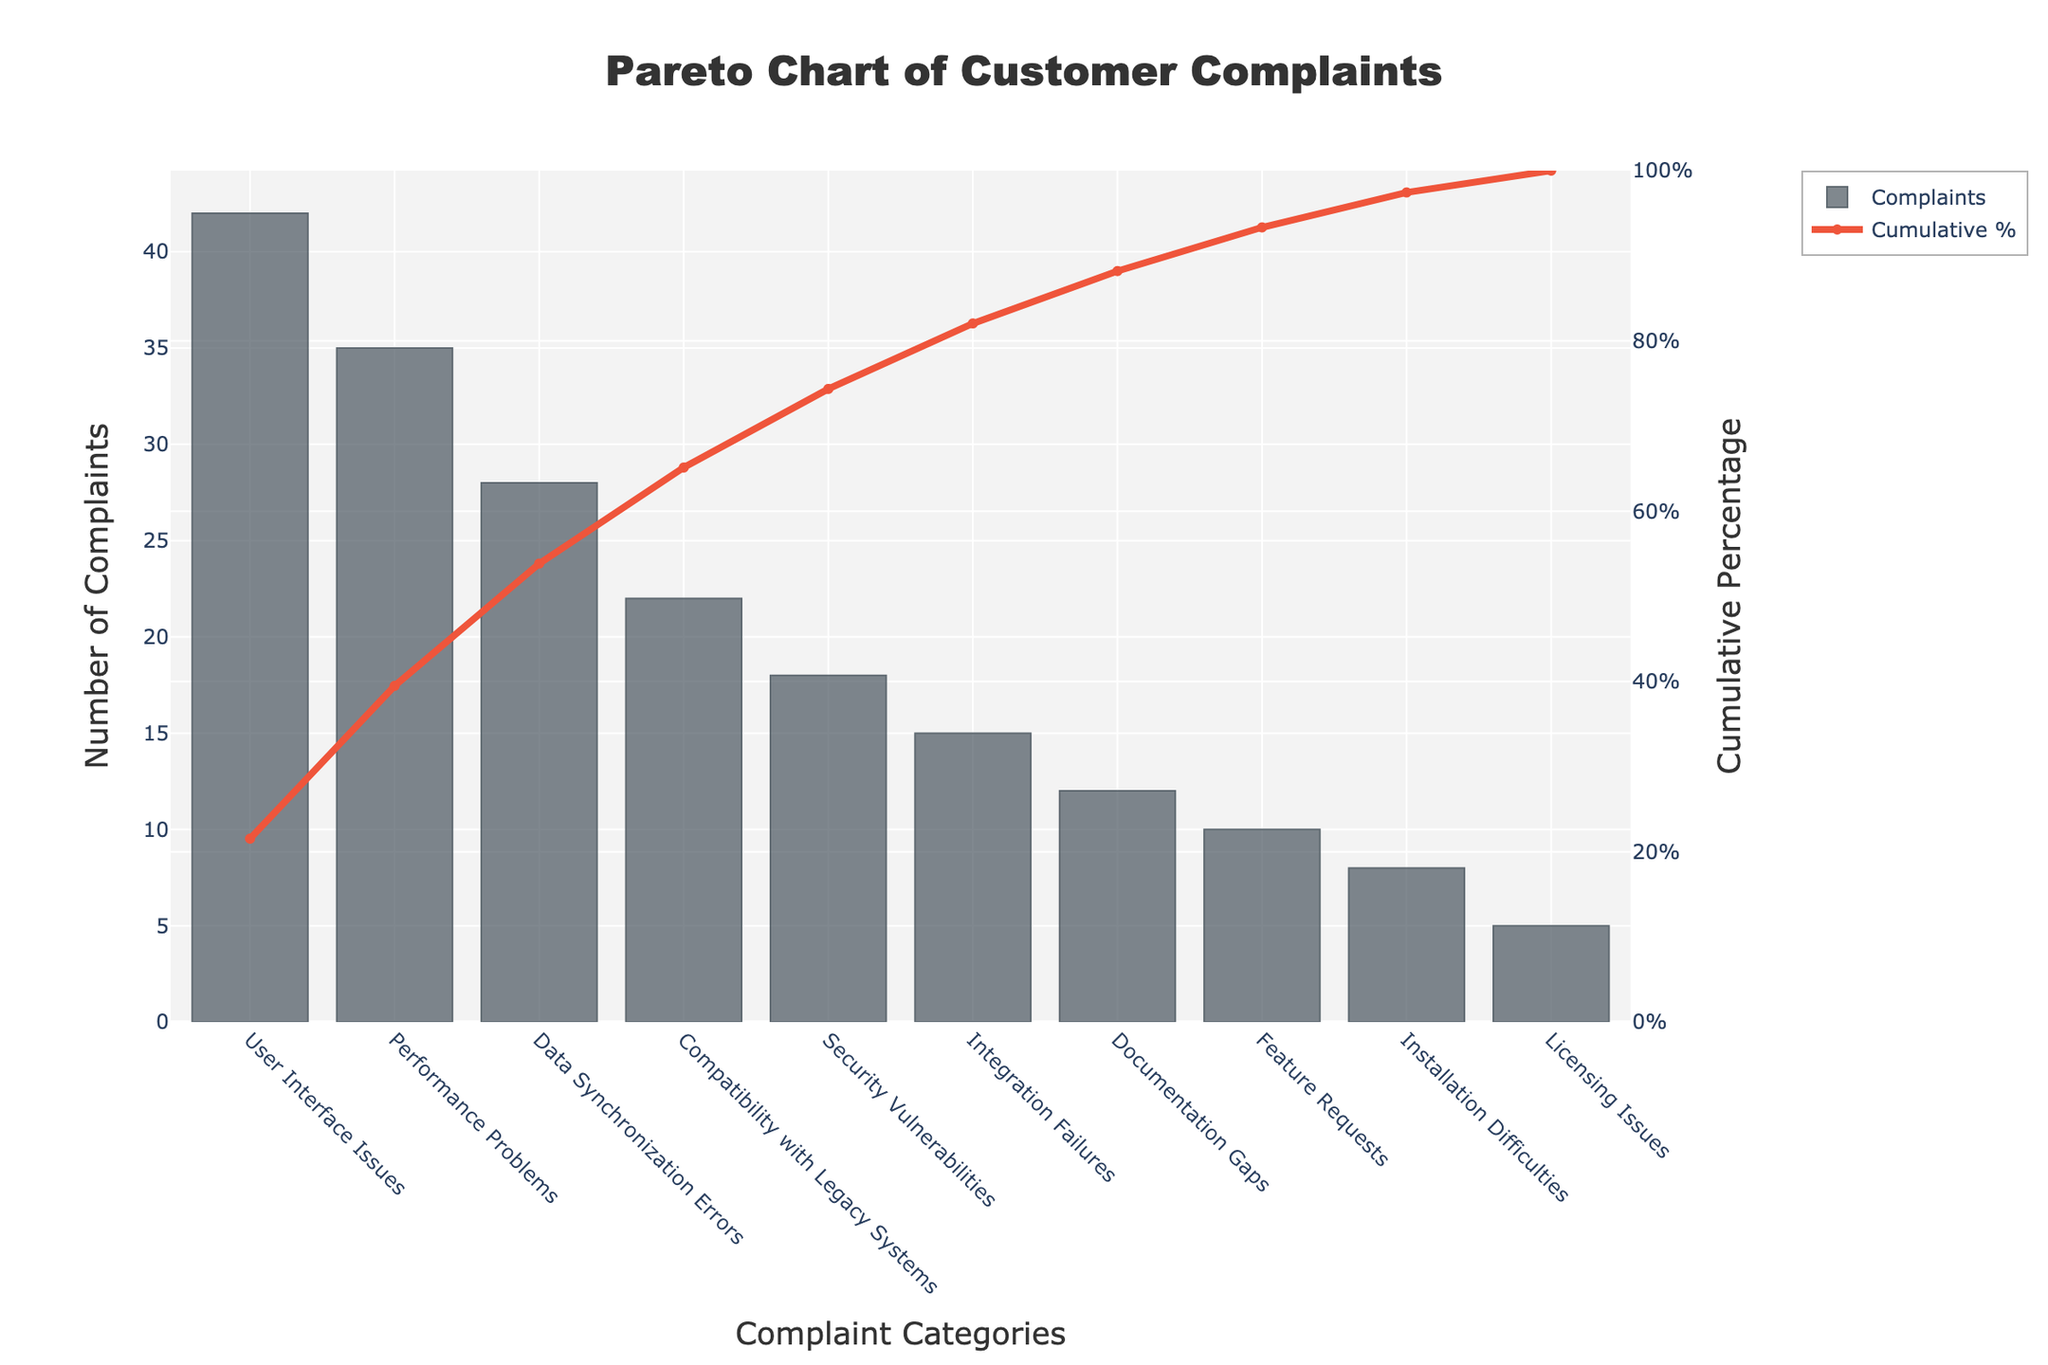What's the title of the chart? The title is usually displayed at the top of the chart. Here, it reads "Pareto Chart of Customer Complaints".
Answer: Pareto Chart of Customer Complaints How many categories of complaints are there in the chart? We can count the number of unique categories listed on the x-axis.
Answer: 10 Which category has the highest number of complaints? Observe the highest bar and read its label. The tallest bar corresponds to “User Interface Issues.”
Answer: User Interface Issues What is the cumulative percentage for 'Data Synchronization Errors’? Find ‘Data Synchronization Errors’ on the x-axis and look at the corresponding point on the line chart to see the cumulative percentage.
Answer: 66.3% What's the combined number of complaints for 'Security Vulnerabilities' and 'Integration Failures'? Add the number of complaints for 'Security Vulnerabilities' (18) and 'Integration Failures' (15). 18 + 15 = 33.
Answer: 33 Which complaint category lies just below 'Compatibility with Legacy Systems' in terms of the number of complaints? In the sorted list by complaint count, the category below 'Compatibility with Legacy Systems' is 'Security Vulnerabilities'.
Answer: Security Vulnerabilities How many complaint categories have fewer than 20 complaints? Count the bars whose heights represent values less than 20. There are six such categories (from 'Security Vulnerabilities' down to 'Licensing Issues').
Answer: 6 What is the cumulative percentage for the third highest complaint category? The third highest category is 'Data Synchronization Errors'. Find its cumulative percentage on the line chart.
Answer: 66.3% Which category contributes to just over 50% of the complaints? Locate on the line chart where the cumulative percentage crosses 50%. The category is 'Performance Problems'.
Answer: Performance Problems What's the total number of complaints in the chart? Sum the values of all the bars: 42 + 35 + 28 + 22 + 18 + 15 + 12 + 10 + 8 + 5 = 195.
Answer: 195 